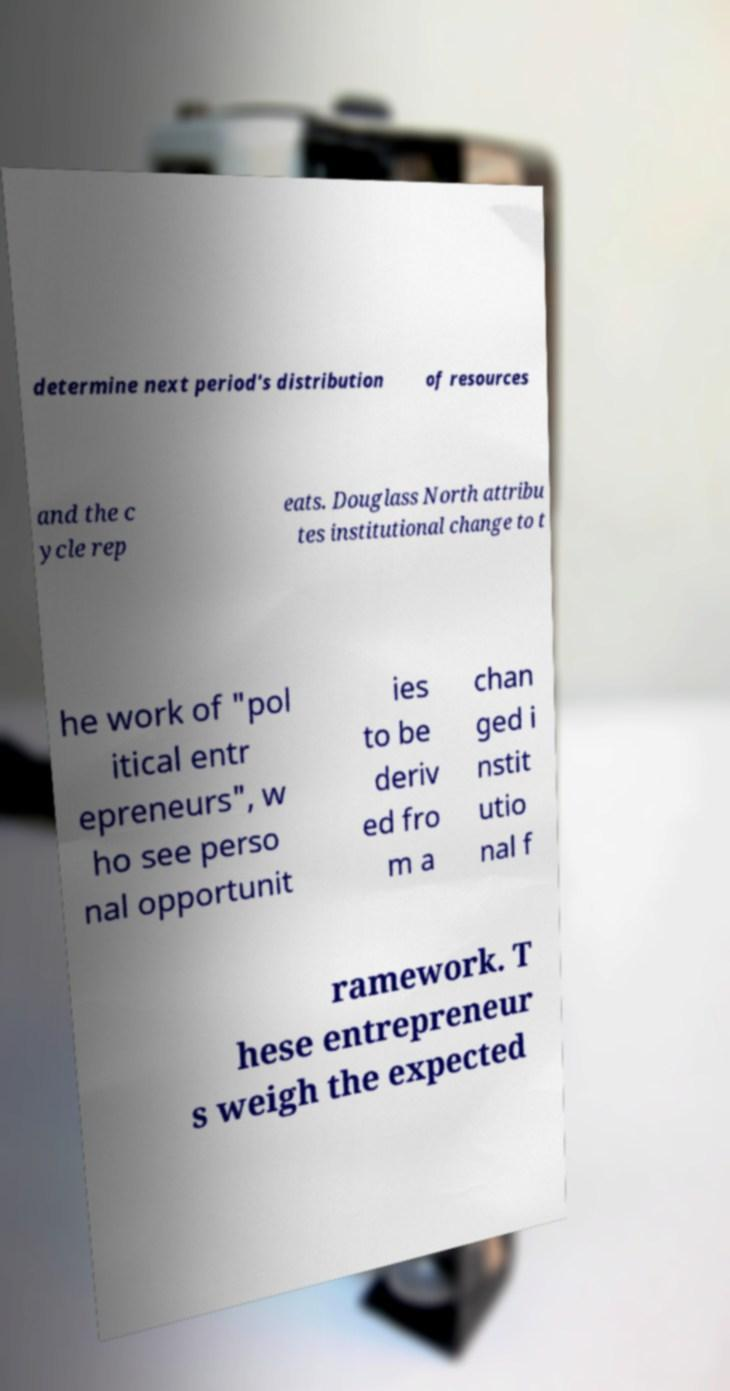There's text embedded in this image that I need extracted. Can you transcribe it verbatim? determine next period's distribution of resources and the c ycle rep eats. Douglass North attribu tes institutional change to t he work of "pol itical entr epreneurs", w ho see perso nal opportunit ies to be deriv ed fro m a chan ged i nstit utio nal f ramework. T hese entrepreneur s weigh the expected 